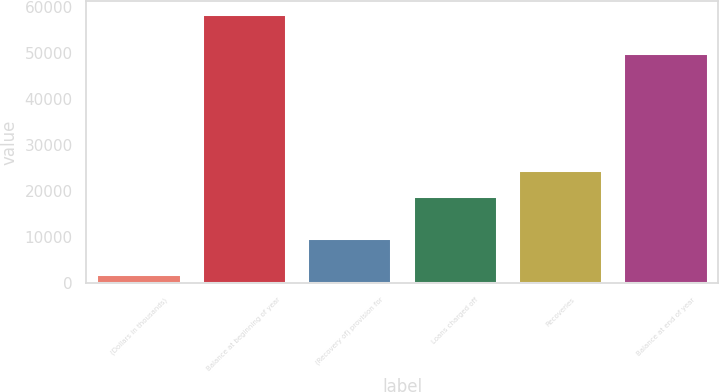Convert chart to OTSL. <chart><loc_0><loc_0><loc_500><loc_500><bar_chart><fcel>(Dollars in thousands)<fcel>Balance at beginning of year<fcel>(Recovery of) provision for<fcel>Loans charged off<fcel>Recoveries<fcel>Balance at end of year<nl><fcel>2003<fcel>58366<fcel>9892<fcel>18975<fcel>24611.3<fcel>49862<nl></chart> 